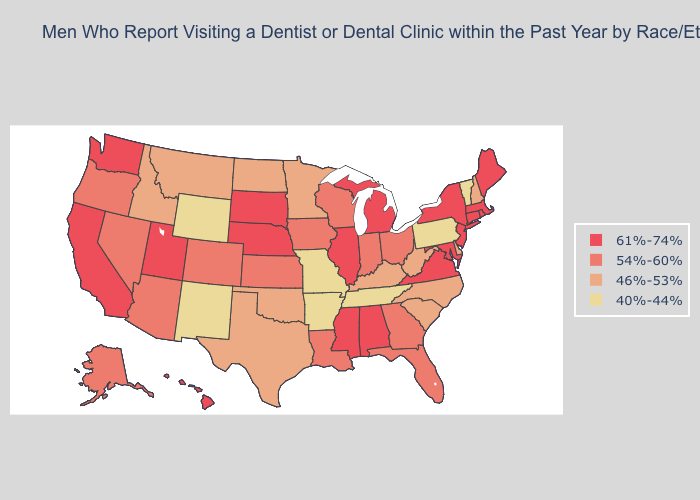What is the lowest value in states that border Massachusetts?
Short answer required. 40%-44%. Name the states that have a value in the range 61%-74%?
Short answer required. Alabama, California, Connecticut, Hawaii, Illinois, Maine, Maryland, Massachusetts, Michigan, Mississippi, Nebraska, New Jersey, New York, Rhode Island, South Dakota, Utah, Virginia, Washington. Does Wisconsin have the highest value in the MidWest?
Short answer required. No. What is the value of Montana?
Quick response, please. 46%-53%. What is the value of Oregon?
Short answer required. 54%-60%. What is the highest value in states that border Nevada?
Quick response, please. 61%-74%. Which states have the highest value in the USA?
Quick response, please. Alabama, California, Connecticut, Hawaii, Illinois, Maine, Maryland, Massachusetts, Michigan, Mississippi, Nebraska, New Jersey, New York, Rhode Island, South Dakota, Utah, Virginia, Washington. Which states have the highest value in the USA?
Short answer required. Alabama, California, Connecticut, Hawaii, Illinois, Maine, Maryland, Massachusetts, Michigan, Mississippi, Nebraska, New Jersey, New York, Rhode Island, South Dakota, Utah, Virginia, Washington. Name the states that have a value in the range 46%-53%?
Concise answer only. Delaware, Idaho, Kentucky, Minnesota, Montana, New Hampshire, North Carolina, North Dakota, Oklahoma, South Carolina, Texas, West Virginia. Does Mississippi have a higher value than Vermont?
Short answer required. Yes. What is the value of Nebraska?
Concise answer only. 61%-74%. What is the lowest value in the USA?
Give a very brief answer. 40%-44%. Does Missouri have the lowest value in the MidWest?
Concise answer only. Yes. What is the value of Nebraska?
Keep it brief. 61%-74%. 